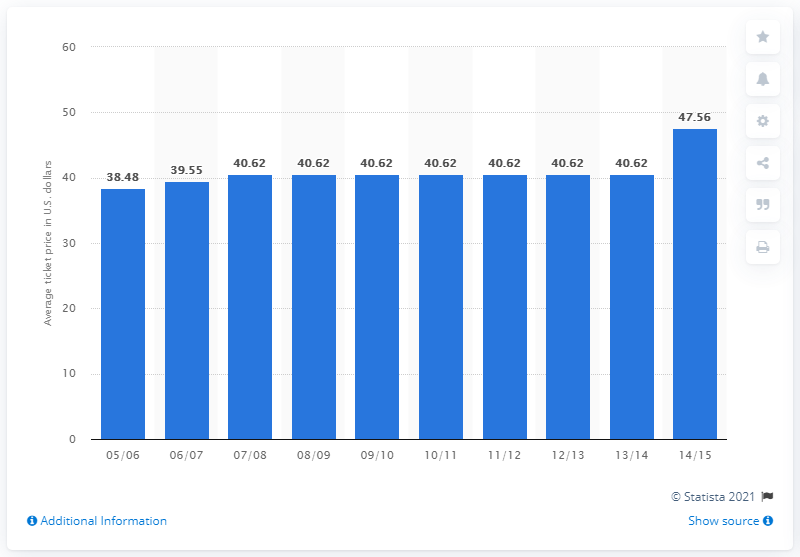List a handful of essential elements in this visual. The average ticket price for the 2005/2006 season was 38.48. 